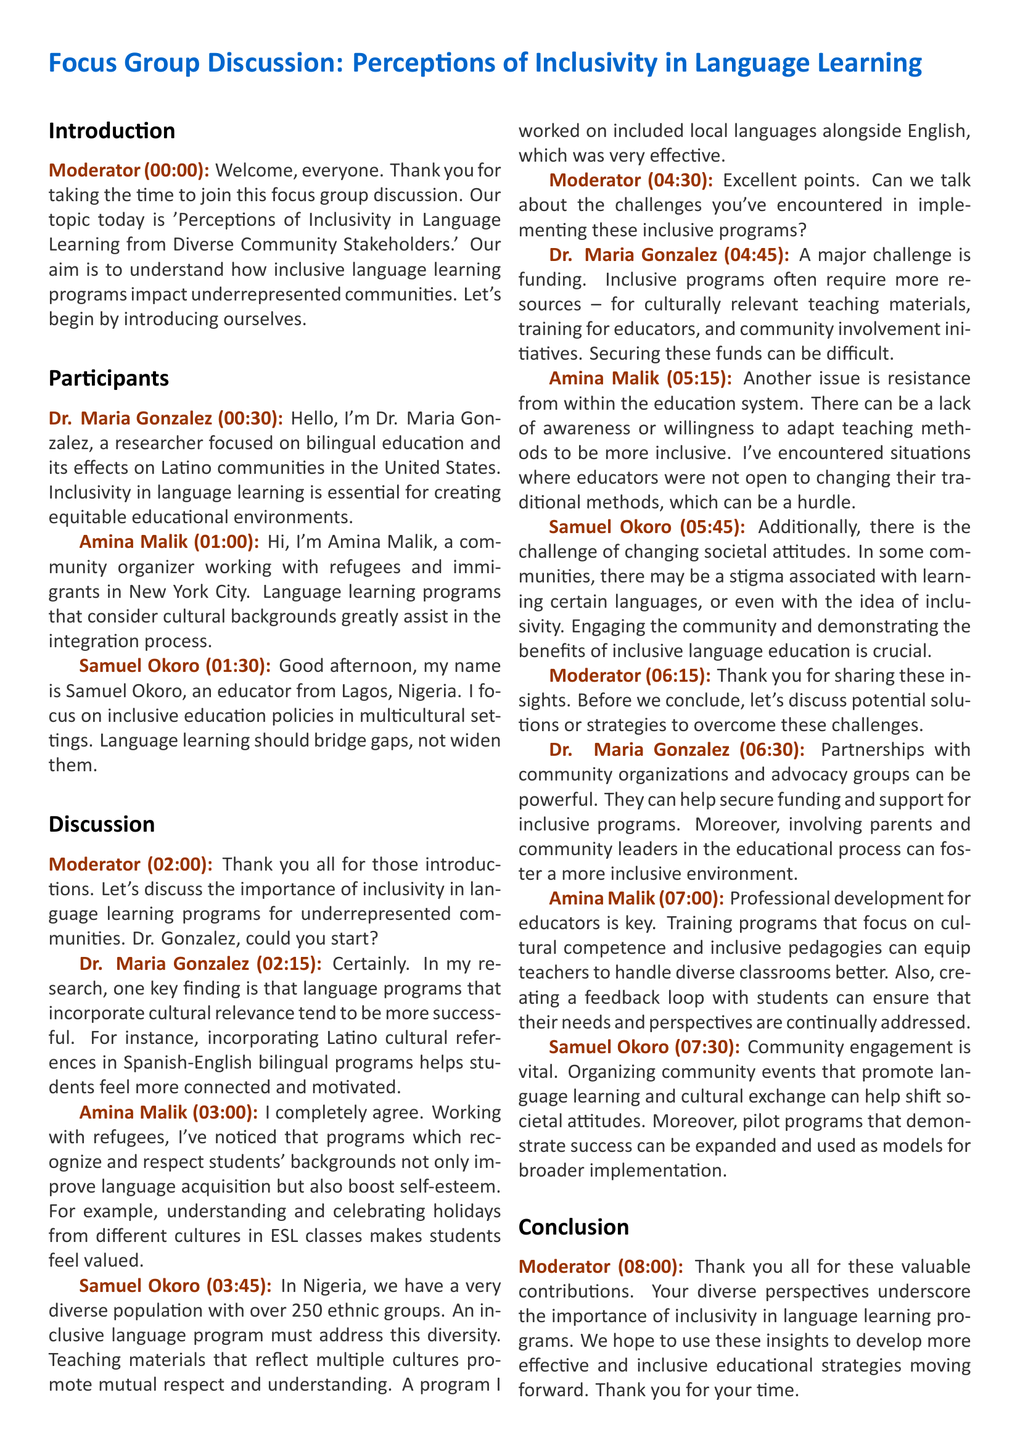What is the topic of the focus group discussion? The topic is 'Perceptions of Inclusivity in Language Learning from Diverse Community Stakeholders.'
Answer: Perceptions of Inclusivity in Language Learning from Diverse Community Stakeholders Who is Dr. Maria Gonzalez? Dr. Maria Gonzalez is a researcher focused on bilingual education and its effects on Latino communities in the United States.
Answer: A researcher focused on bilingual education What is Amina Malik's role in the community? Amina Malik is a community organizer working with refugees and immigrants in New York City.
Answer: Community organizer How many ethnic groups are there in Nigeria according to Samuel Okoro? According to Samuel Okoro, there are over 250 ethnic groups in Nigeria.
Answer: Over 250 What is one key challenge mentioned by Dr. Maria Gonzalez? A major challenge mentioned is funding for inclusive programs.
Answer: Funding What is a proposed strategy by Amina Malik for improving inclusivity? Amina Malik suggests professional development for educators to enhance cultural competence.
Answer: Professional development for educators What kind of engagement does Samuel Okoro emphasize as vital? Samuel Okoro emphasizes community engagement as vital.
Answer: Community engagement What was one of the key solutions suggested for funding inclusive programs? Partnerships with community organizations and advocacy groups can help secure funding.
Answer: Partnerships with community organizations 